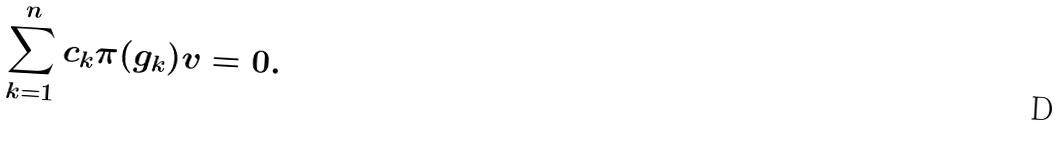<formula> <loc_0><loc_0><loc_500><loc_500>\sum _ { k = 1 } ^ { n } c _ { k } \pi ( g _ { k } ) v = 0 .</formula> 